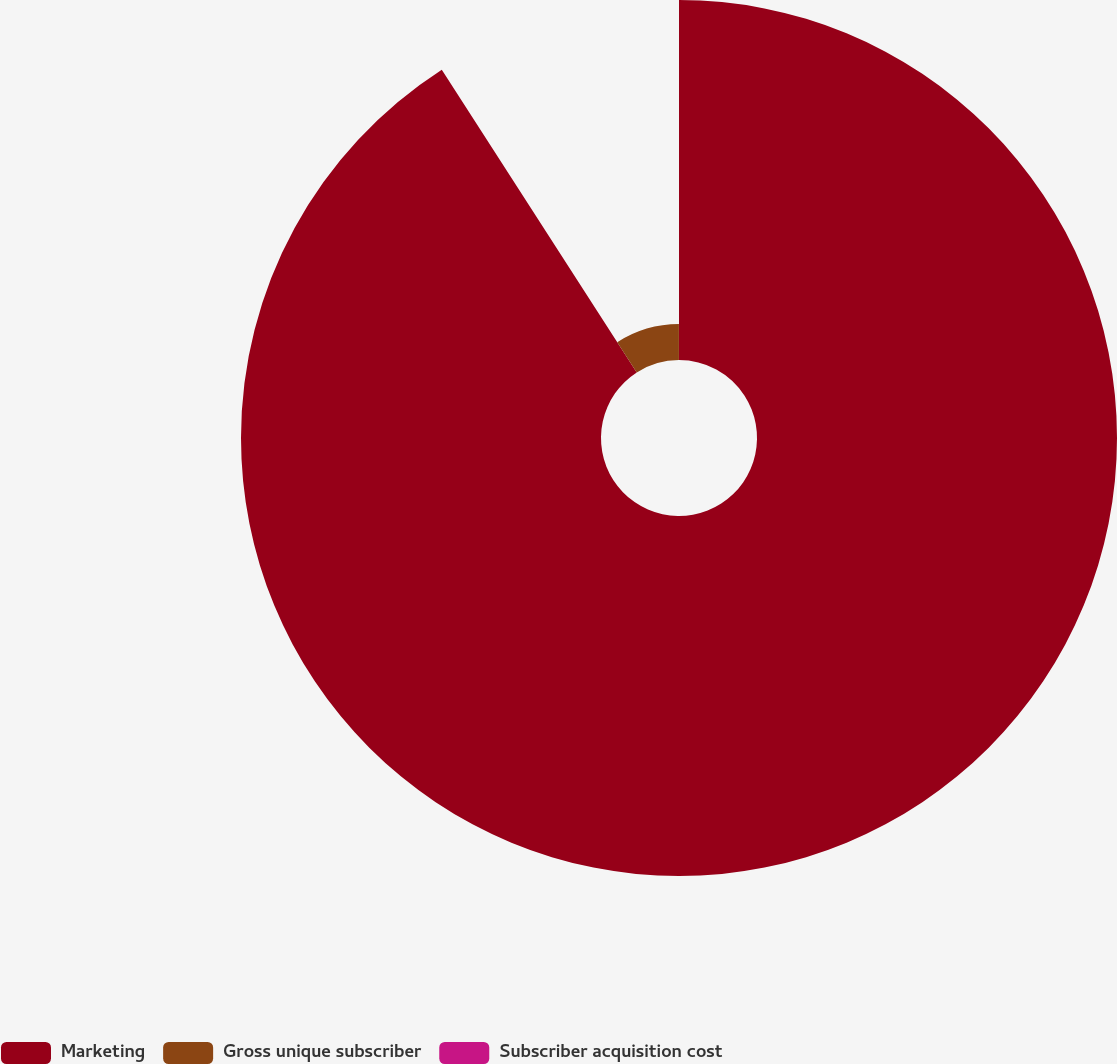<chart> <loc_0><loc_0><loc_500><loc_500><pie_chart><fcel>Marketing<fcel>Gross unique subscriber<fcel>Subscriber acquisition cost<nl><fcel>90.9%<fcel>9.1%<fcel>0.01%<nl></chart> 